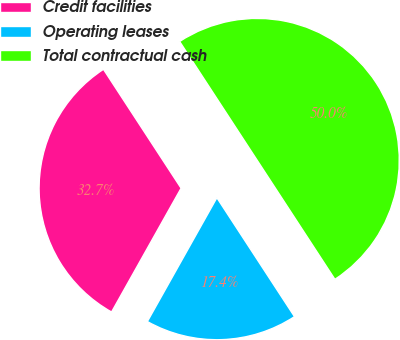<chart> <loc_0><loc_0><loc_500><loc_500><pie_chart><fcel>Credit facilities<fcel>Operating leases<fcel>Total contractual cash<nl><fcel>32.65%<fcel>17.35%<fcel>50.0%<nl></chart> 